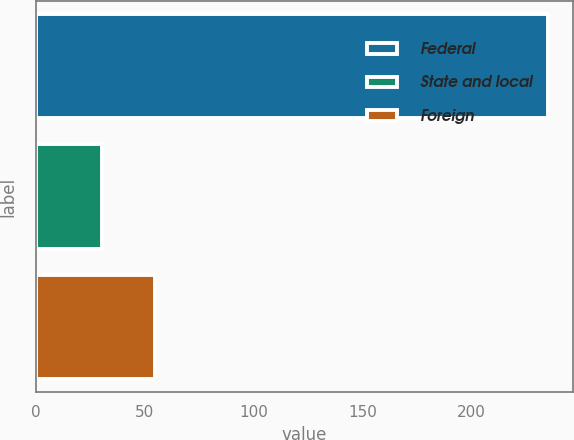<chart> <loc_0><loc_0><loc_500><loc_500><bar_chart><fcel>Federal<fcel>State and local<fcel>Foreign<nl><fcel>234.8<fcel>30.3<fcel>54.6<nl></chart> 